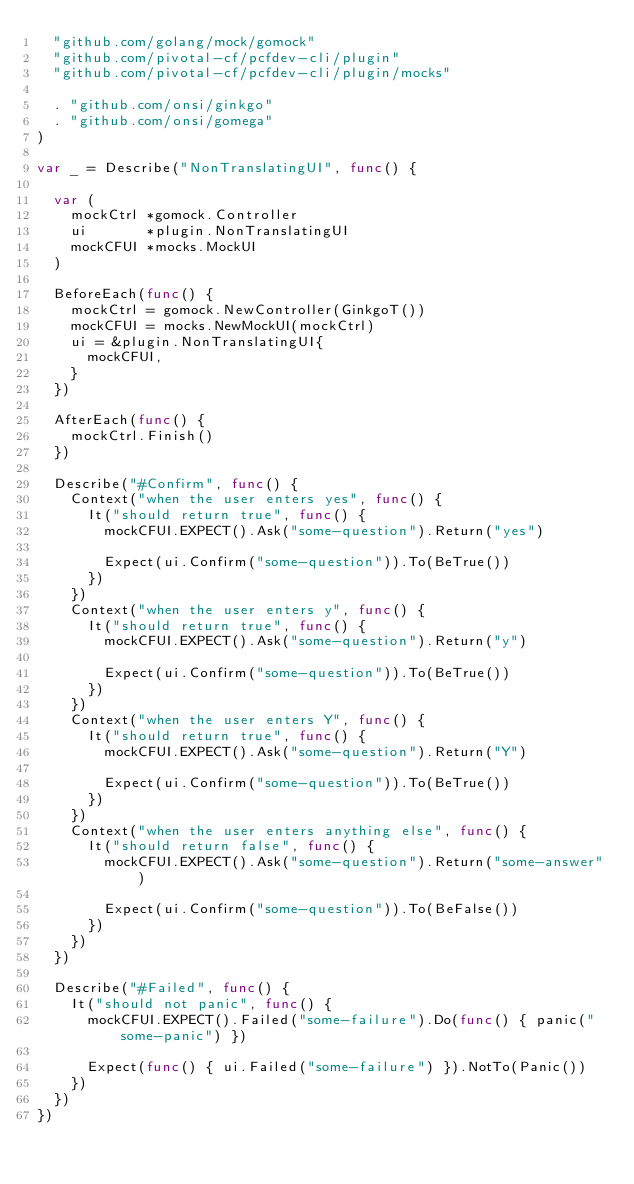<code> <loc_0><loc_0><loc_500><loc_500><_Go_>	"github.com/golang/mock/gomock"
	"github.com/pivotal-cf/pcfdev-cli/plugin"
	"github.com/pivotal-cf/pcfdev-cli/plugin/mocks"

	. "github.com/onsi/ginkgo"
	. "github.com/onsi/gomega"
)

var _ = Describe("NonTranslatingUI", func() {

	var (
		mockCtrl *gomock.Controller
		ui       *plugin.NonTranslatingUI
		mockCFUI *mocks.MockUI
	)

	BeforeEach(func() {
		mockCtrl = gomock.NewController(GinkgoT())
		mockCFUI = mocks.NewMockUI(mockCtrl)
		ui = &plugin.NonTranslatingUI{
			mockCFUI,
		}
	})

	AfterEach(func() {
		mockCtrl.Finish()
	})

	Describe("#Confirm", func() {
		Context("when the user enters yes", func() {
			It("should return true", func() {
				mockCFUI.EXPECT().Ask("some-question").Return("yes")

				Expect(ui.Confirm("some-question")).To(BeTrue())
			})
		})
		Context("when the user enters y", func() {
			It("should return true", func() {
				mockCFUI.EXPECT().Ask("some-question").Return("y")

				Expect(ui.Confirm("some-question")).To(BeTrue())
			})
		})
		Context("when the user enters Y", func() {
			It("should return true", func() {
				mockCFUI.EXPECT().Ask("some-question").Return("Y")

				Expect(ui.Confirm("some-question")).To(BeTrue())
			})
		})
		Context("when the user enters anything else", func() {
			It("should return false", func() {
				mockCFUI.EXPECT().Ask("some-question").Return("some-answer")

				Expect(ui.Confirm("some-question")).To(BeFalse())
			})
		})
	})

	Describe("#Failed", func() {
		It("should not panic", func() {
			mockCFUI.EXPECT().Failed("some-failure").Do(func() { panic("some-panic") })

			Expect(func() { ui.Failed("some-failure") }).NotTo(Panic())
		})
	})
})
</code> 